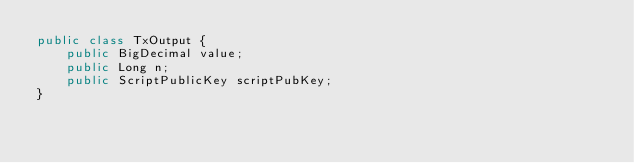Convert code to text. <code><loc_0><loc_0><loc_500><loc_500><_Java_>public class TxOutput {
    public BigDecimal value;
    public Long n;
    public ScriptPublicKey scriptPubKey;
}
</code> 